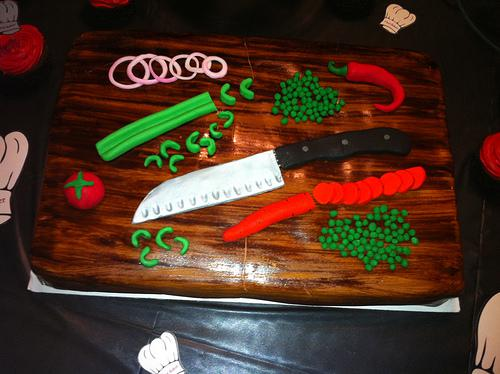Question: why is the object in the photo?
Choices:
A. Cookies.
B. Cupcakes.
C. Muffins.
D. Cake.
Answer with the letter. Answer: D Question: what vegetable is directly under the knife?
Choices:
A. Carrot.
B. Celery.
C. Broccoli.
D. Brussel sprout.
Answer with the letter. Answer: A Question: who is standing in front of the cake?
Choices:
A. The man.
B. My Mom.
C. The child.
D. No one.
Answer with the letter. Answer: D 